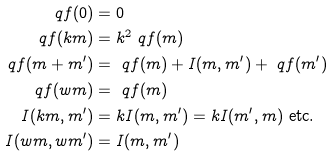<formula> <loc_0><loc_0><loc_500><loc_500>\ q f ( 0 ) & = 0 \\ \ q f ( k m ) & = k ^ { 2 } \ q f ( m ) \\ \ q f ( m + m ^ { \prime } ) & = \ q f ( m ) + I ( m , m ^ { \prime } ) + \ q f ( m ^ { \prime } ) \\ \ q f ( w m ) & = \ q f ( m ) \\ I ( k m , m ^ { \prime } ) & = k I ( m , m ^ { \prime } ) = k I ( m ^ { \prime } , m ) \text { etc.} \\ I ( w m , w m ^ { \prime } ) & = I ( m , m ^ { \prime } )</formula> 